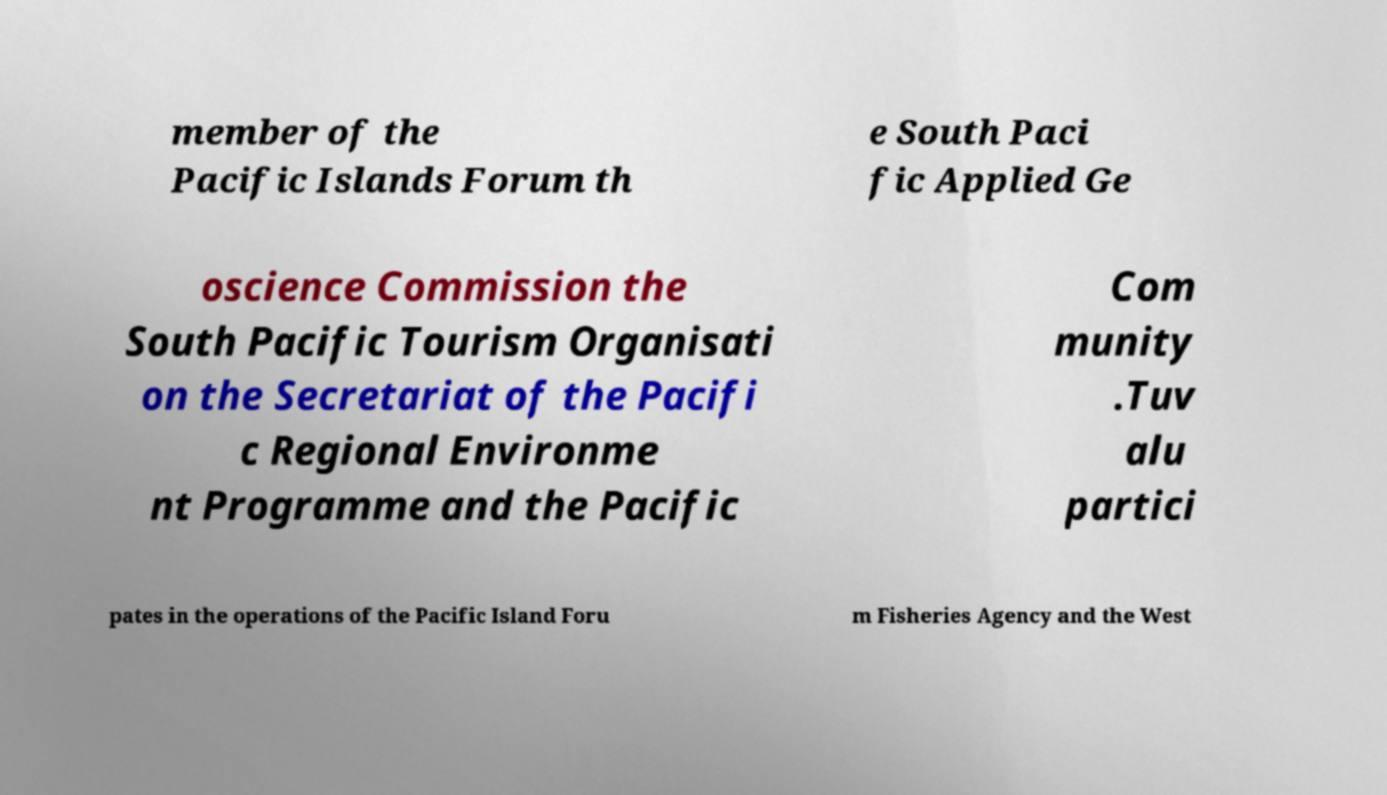Could you assist in decoding the text presented in this image and type it out clearly? member of the Pacific Islands Forum th e South Paci fic Applied Ge oscience Commission the South Pacific Tourism Organisati on the Secretariat of the Pacifi c Regional Environme nt Programme and the Pacific Com munity .Tuv alu partici pates in the operations of the Pacific Island Foru m Fisheries Agency and the West 